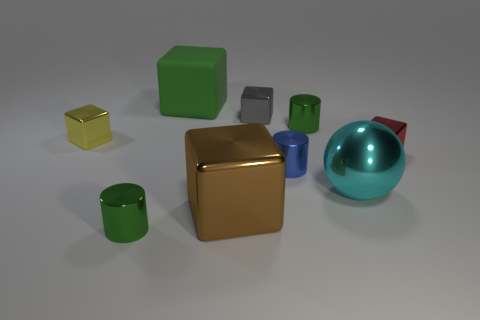Subtract 1 blocks. How many blocks are left? 4 Subtract all green cubes. How many cubes are left? 4 Subtract all gray metal cubes. How many cubes are left? 4 Subtract all blue cubes. Subtract all gray spheres. How many cubes are left? 5 Subtract all cylinders. How many objects are left? 6 Subtract 1 green cubes. How many objects are left? 8 Subtract all small blocks. Subtract all tiny metal cubes. How many objects are left? 3 Add 1 green cylinders. How many green cylinders are left? 3 Add 7 big red shiny objects. How many big red shiny objects exist? 7 